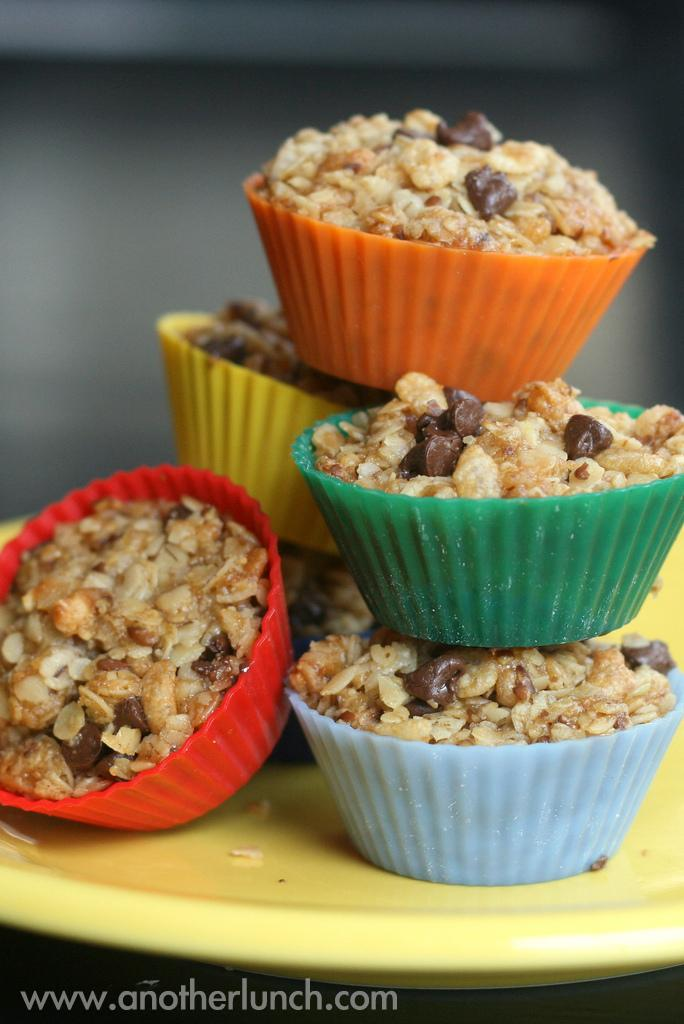What is on the plate in the image? There are food items on a plate in the image. What color is the plate? The plate is yellow in color. What type of flag is being waved by the spy in the image? There is no flag or spy present in the image; it only features a plate with food items and a yellow plate. 